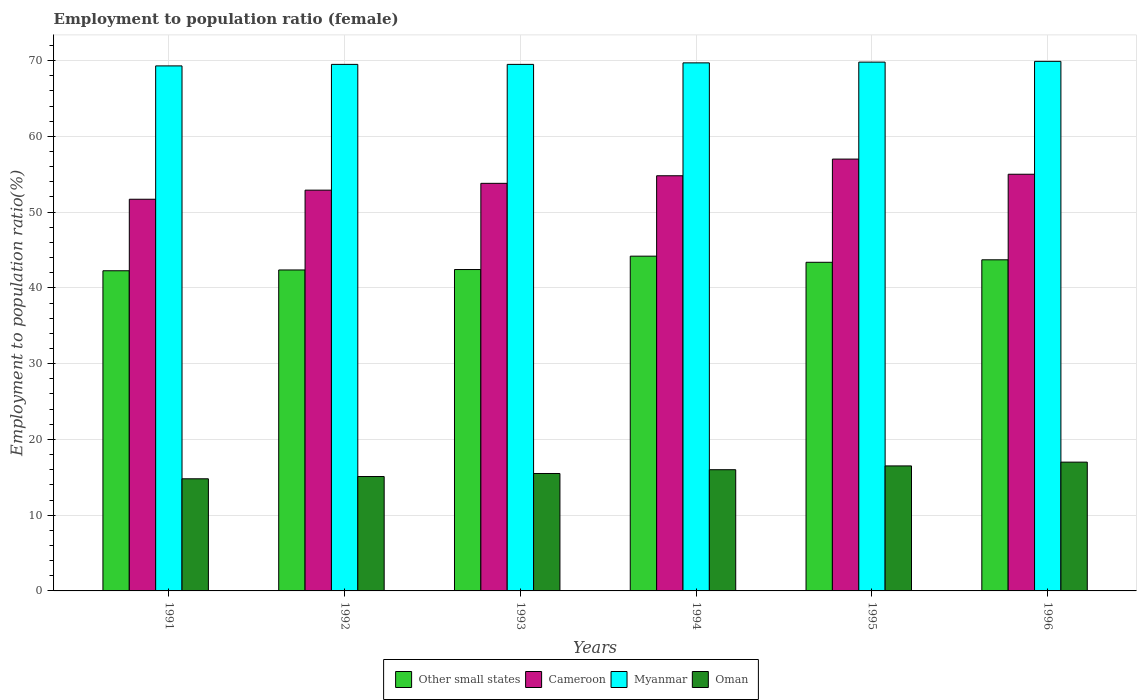How many groups of bars are there?
Offer a terse response. 6. Are the number of bars on each tick of the X-axis equal?
Your response must be concise. Yes. How many bars are there on the 4th tick from the right?
Your response must be concise. 4. What is the label of the 3rd group of bars from the left?
Your answer should be compact. 1993. In how many cases, is the number of bars for a given year not equal to the number of legend labels?
Your answer should be compact. 0. What is the employment to population ratio in Myanmar in 1993?
Your response must be concise. 69.5. Across all years, what is the maximum employment to population ratio in Oman?
Make the answer very short. 17. Across all years, what is the minimum employment to population ratio in Cameroon?
Provide a short and direct response. 51.7. In which year was the employment to population ratio in Cameroon minimum?
Give a very brief answer. 1991. What is the total employment to population ratio in Cameroon in the graph?
Keep it short and to the point. 325.2. What is the difference between the employment to population ratio in Cameroon in 1991 and the employment to population ratio in Oman in 1996?
Offer a terse response. 34.7. What is the average employment to population ratio in Other small states per year?
Ensure brevity in your answer.  43.05. In the year 1995, what is the difference between the employment to population ratio in Cameroon and employment to population ratio in Oman?
Ensure brevity in your answer.  40.5. In how many years, is the employment to population ratio in Oman greater than 60 %?
Ensure brevity in your answer.  0. What is the ratio of the employment to population ratio in Other small states in 1992 to that in 1996?
Offer a terse response. 0.97. What is the difference between the highest and the lowest employment to population ratio in Oman?
Provide a succinct answer. 2.2. In how many years, is the employment to population ratio in Other small states greater than the average employment to population ratio in Other small states taken over all years?
Offer a terse response. 3. What does the 1st bar from the left in 1996 represents?
Keep it short and to the point. Other small states. What does the 4th bar from the right in 1996 represents?
Provide a short and direct response. Other small states. Is it the case that in every year, the sum of the employment to population ratio in Myanmar and employment to population ratio in Cameroon is greater than the employment to population ratio in Oman?
Give a very brief answer. Yes. Are all the bars in the graph horizontal?
Your answer should be very brief. No. How many years are there in the graph?
Offer a very short reply. 6. What is the difference between two consecutive major ticks on the Y-axis?
Your answer should be compact. 10. Are the values on the major ticks of Y-axis written in scientific E-notation?
Your response must be concise. No. Does the graph contain any zero values?
Make the answer very short. No. Does the graph contain grids?
Offer a terse response. Yes. Where does the legend appear in the graph?
Your answer should be compact. Bottom center. How are the legend labels stacked?
Make the answer very short. Horizontal. What is the title of the graph?
Your answer should be compact. Employment to population ratio (female). Does "Tanzania" appear as one of the legend labels in the graph?
Your response must be concise. No. What is the label or title of the X-axis?
Your answer should be very brief. Years. What is the label or title of the Y-axis?
Your answer should be compact. Employment to population ratio(%). What is the Employment to population ratio(%) in Other small states in 1991?
Your answer should be compact. 42.26. What is the Employment to population ratio(%) of Cameroon in 1991?
Your response must be concise. 51.7. What is the Employment to population ratio(%) in Myanmar in 1991?
Your answer should be very brief. 69.3. What is the Employment to population ratio(%) of Oman in 1991?
Your answer should be very brief. 14.8. What is the Employment to population ratio(%) in Other small states in 1992?
Make the answer very short. 42.36. What is the Employment to population ratio(%) of Cameroon in 1992?
Your answer should be compact. 52.9. What is the Employment to population ratio(%) of Myanmar in 1992?
Keep it short and to the point. 69.5. What is the Employment to population ratio(%) in Oman in 1992?
Your answer should be very brief. 15.1. What is the Employment to population ratio(%) in Other small states in 1993?
Give a very brief answer. 42.42. What is the Employment to population ratio(%) in Cameroon in 1993?
Give a very brief answer. 53.8. What is the Employment to population ratio(%) in Myanmar in 1993?
Your response must be concise. 69.5. What is the Employment to population ratio(%) in Other small states in 1994?
Provide a succinct answer. 44.19. What is the Employment to population ratio(%) of Cameroon in 1994?
Your answer should be very brief. 54.8. What is the Employment to population ratio(%) of Myanmar in 1994?
Your answer should be very brief. 69.7. What is the Employment to population ratio(%) in Oman in 1994?
Your answer should be very brief. 16. What is the Employment to population ratio(%) of Other small states in 1995?
Give a very brief answer. 43.38. What is the Employment to population ratio(%) in Cameroon in 1995?
Offer a terse response. 57. What is the Employment to population ratio(%) of Myanmar in 1995?
Ensure brevity in your answer.  69.8. What is the Employment to population ratio(%) of Oman in 1995?
Your answer should be very brief. 16.5. What is the Employment to population ratio(%) in Other small states in 1996?
Your response must be concise. 43.71. What is the Employment to population ratio(%) in Myanmar in 1996?
Ensure brevity in your answer.  69.9. What is the Employment to population ratio(%) of Oman in 1996?
Your answer should be very brief. 17. Across all years, what is the maximum Employment to population ratio(%) in Other small states?
Give a very brief answer. 44.19. Across all years, what is the maximum Employment to population ratio(%) in Myanmar?
Offer a very short reply. 69.9. Across all years, what is the minimum Employment to population ratio(%) of Other small states?
Offer a very short reply. 42.26. Across all years, what is the minimum Employment to population ratio(%) of Cameroon?
Keep it short and to the point. 51.7. Across all years, what is the minimum Employment to population ratio(%) of Myanmar?
Offer a very short reply. 69.3. Across all years, what is the minimum Employment to population ratio(%) of Oman?
Your answer should be compact. 14.8. What is the total Employment to population ratio(%) of Other small states in the graph?
Your answer should be very brief. 258.31. What is the total Employment to population ratio(%) of Cameroon in the graph?
Make the answer very short. 325.2. What is the total Employment to population ratio(%) in Myanmar in the graph?
Offer a very short reply. 417.7. What is the total Employment to population ratio(%) in Oman in the graph?
Your response must be concise. 94.9. What is the difference between the Employment to population ratio(%) in Other small states in 1991 and that in 1992?
Your answer should be compact. -0.1. What is the difference between the Employment to population ratio(%) in Myanmar in 1991 and that in 1992?
Offer a terse response. -0.2. What is the difference between the Employment to population ratio(%) in Other small states in 1991 and that in 1993?
Your answer should be very brief. -0.16. What is the difference between the Employment to population ratio(%) of Cameroon in 1991 and that in 1993?
Your response must be concise. -2.1. What is the difference between the Employment to population ratio(%) in Other small states in 1991 and that in 1994?
Make the answer very short. -1.93. What is the difference between the Employment to population ratio(%) of Myanmar in 1991 and that in 1994?
Provide a succinct answer. -0.4. What is the difference between the Employment to population ratio(%) in Other small states in 1991 and that in 1995?
Provide a succinct answer. -1.12. What is the difference between the Employment to population ratio(%) in Other small states in 1991 and that in 1996?
Keep it short and to the point. -1.45. What is the difference between the Employment to population ratio(%) in Oman in 1991 and that in 1996?
Provide a succinct answer. -2.2. What is the difference between the Employment to population ratio(%) in Other small states in 1992 and that in 1993?
Provide a succinct answer. -0.06. What is the difference between the Employment to population ratio(%) of Myanmar in 1992 and that in 1993?
Provide a short and direct response. 0. What is the difference between the Employment to population ratio(%) of Other small states in 1992 and that in 1994?
Give a very brief answer. -1.82. What is the difference between the Employment to population ratio(%) in Cameroon in 1992 and that in 1994?
Your answer should be very brief. -1.9. What is the difference between the Employment to population ratio(%) in Myanmar in 1992 and that in 1994?
Make the answer very short. -0.2. What is the difference between the Employment to population ratio(%) in Other small states in 1992 and that in 1995?
Make the answer very short. -1.01. What is the difference between the Employment to population ratio(%) in Cameroon in 1992 and that in 1995?
Keep it short and to the point. -4.1. What is the difference between the Employment to population ratio(%) of Oman in 1992 and that in 1995?
Give a very brief answer. -1.4. What is the difference between the Employment to population ratio(%) in Other small states in 1992 and that in 1996?
Provide a short and direct response. -1.34. What is the difference between the Employment to population ratio(%) in Cameroon in 1992 and that in 1996?
Provide a succinct answer. -2.1. What is the difference between the Employment to population ratio(%) of Myanmar in 1992 and that in 1996?
Provide a short and direct response. -0.4. What is the difference between the Employment to population ratio(%) of Other small states in 1993 and that in 1994?
Your answer should be very brief. -1.76. What is the difference between the Employment to population ratio(%) of Cameroon in 1993 and that in 1994?
Provide a succinct answer. -1. What is the difference between the Employment to population ratio(%) in Myanmar in 1993 and that in 1994?
Provide a short and direct response. -0.2. What is the difference between the Employment to population ratio(%) of Oman in 1993 and that in 1994?
Provide a succinct answer. -0.5. What is the difference between the Employment to population ratio(%) of Other small states in 1993 and that in 1995?
Your answer should be very brief. -0.96. What is the difference between the Employment to population ratio(%) of Oman in 1993 and that in 1995?
Your response must be concise. -1. What is the difference between the Employment to population ratio(%) of Other small states in 1993 and that in 1996?
Offer a terse response. -1.29. What is the difference between the Employment to population ratio(%) in Myanmar in 1993 and that in 1996?
Give a very brief answer. -0.4. What is the difference between the Employment to population ratio(%) of Oman in 1993 and that in 1996?
Your response must be concise. -1.5. What is the difference between the Employment to population ratio(%) in Other small states in 1994 and that in 1995?
Your answer should be compact. 0.81. What is the difference between the Employment to population ratio(%) of Myanmar in 1994 and that in 1995?
Provide a succinct answer. -0.1. What is the difference between the Employment to population ratio(%) in Other small states in 1994 and that in 1996?
Your response must be concise. 0.48. What is the difference between the Employment to population ratio(%) of Cameroon in 1994 and that in 1996?
Your answer should be compact. -0.2. What is the difference between the Employment to population ratio(%) in Myanmar in 1994 and that in 1996?
Your response must be concise. -0.2. What is the difference between the Employment to population ratio(%) in Other small states in 1995 and that in 1996?
Provide a succinct answer. -0.33. What is the difference between the Employment to population ratio(%) in Other small states in 1991 and the Employment to population ratio(%) in Cameroon in 1992?
Ensure brevity in your answer.  -10.64. What is the difference between the Employment to population ratio(%) of Other small states in 1991 and the Employment to population ratio(%) of Myanmar in 1992?
Ensure brevity in your answer.  -27.24. What is the difference between the Employment to population ratio(%) in Other small states in 1991 and the Employment to population ratio(%) in Oman in 1992?
Ensure brevity in your answer.  27.16. What is the difference between the Employment to population ratio(%) in Cameroon in 1991 and the Employment to population ratio(%) in Myanmar in 1992?
Your response must be concise. -17.8. What is the difference between the Employment to population ratio(%) in Cameroon in 1991 and the Employment to population ratio(%) in Oman in 1992?
Your answer should be very brief. 36.6. What is the difference between the Employment to population ratio(%) in Myanmar in 1991 and the Employment to population ratio(%) in Oman in 1992?
Provide a succinct answer. 54.2. What is the difference between the Employment to population ratio(%) of Other small states in 1991 and the Employment to population ratio(%) of Cameroon in 1993?
Keep it short and to the point. -11.54. What is the difference between the Employment to population ratio(%) of Other small states in 1991 and the Employment to population ratio(%) of Myanmar in 1993?
Keep it short and to the point. -27.24. What is the difference between the Employment to population ratio(%) in Other small states in 1991 and the Employment to population ratio(%) in Oman in 1993?
Make the answer very short. 26.76. What is the difference between the Employment to population ratio(%) in Cameroon in 1991 and the Employment to population ratio(%) in Myanmar in 1993?
Provide a succinct answer. -17.8. What is the difference between the Employment to population ratio(%) of Cameroon in 1991 and the Employment to population ratio(%) of Oman in 1993?
Make the answer very short. 36.2. What is the difference between the Employment to population ratio(%) of Myanmar in 1991 and the Employment to population ratio(%) of Oman in 1993?
Ensure brevity in your answer.  53.8. What is the difference between the Employment to population ratio(%) of Other small states in 1991 and the Employment to population ratio(%) of Cameroon in 1994?
Ensure brevity in your answer.  -12.54. What is the difference between the Employment to population ratio(%) in Other small states in 1991 and the Employment to population ratio(%) in Myanmar in 1994?
Give a very brief answer. -27.44. What is the difference between the Employment to population ratio(%) of Other small states in 1991 and the Employment to population ratio(%) of Oman in 1994?
Give a very brief answer. 26.26. What is the difference between the Employment to population ratio(%) in Cameroon in 1991 and the Employment to population ratio(%) in Myanmar in 1994?
Ensure brevity in your answer.  -18. What is the difference between the Employment to population ratio(%) of Cameroon in 1991 and the Employment to population ratio(%) of Oman in 1994?
Provide a short and direct response. 35.7. What is the difference between the Employment to population ratio(%) in Myanmar in 1991 and the Employment to population ratio(%) in Oman in 1994?
Ensure brevity in your answer.  53.3. What is the difference between the Employment to population ratio(%) in Other small states in 1991 and the Employment to population ratio(%) in Cameroon in 1995?
Make the answer very short. -14.74. What is the difference between the Employment to population ratio(%) in Other small states in 1991 and the Employment to population ratio(%) in Myanmar in 1995?
Keep it short and to the point. -27.54. What is the difference between the Employment to population ratio(%) of Other small states in 1991 and the Employment to population ratio(%) of Oman in 1995?
Your answer should be compact. 25.76. What is the difference between the Employment to population ratio(%) of Cameroon in 1991 and the Employment to population ratio(%) of Myanmar in 1995?
Offer a very short reply. -18.1. What is the difference between the Employment to population ratio(%) of Cameroon in 1991 and the Employment to population ratio(%) of Oman in 1995?
Provide a short and direct response. 35.2. What is the difference between the Employment to population ratio(%) of Myanmar in 1991 and the Employment to population ratio(%) of Oman in 1995?
Give a very brief answer. 52.8. What is the difference between the Employment to population ratio(%) in Other small states in 1991 and the Employment to population ratio(%) in Cameroon in 1996?
Provide a succinct answer. -12.74. What is the difference between the Employment to population ratio(%) in Other small states in 1991 and the Employment to population ratio(%) in Myanmar in 1996?
Provide a succinct answer. -27.64. What is the difference between the Employment to population ratio(%) in Other small states in 1991 and the Employment to population ratio(%) in Oman in 1996?
Provide a succinct answer. 25.26. What is the difference between the Employment to population ratio(%) of Cameroon in 1991 and the Employment to population ratio(%) of Myanmar in 1996?
Ensure brevity in your answer.  -18.2. What is the difference between the Employment to population ratio(%) of Cameroon in 1991 and the Employment to population ratio(%) of Oman in 1996?
Ensure brevity in your answer.  34.7. What is the difference between the Employment to population ratio(%) of Myanmar in 1991 and the Employment to population ratio(%) of Oman in 1996?
Keep it short and to the point. 52.3. What is the difference between the Employment to population ratio(%) of Other small states in 1992 and the Employment to population ratio(%) of Cameroon in 1993?
Your answer should be very brief. -11.44. What is the difference between the Employment to population ratio(%) of Other small states in 1992 and the Employment to population ratio(%) of Myanmar in 1993?
Provide a succinct answer. -27.14. What is the difference between the Employment to population ratio(%) in Other small states in 1992 and the Employment to population ratio(%) in Oman in 1993?
Give a very brief answer. 26.86. What is the difference between the Employment to population ratio(%) in Cameroon in 1992 and the Employment to population ratio(%) in Myanmar in 1993?
Make the answer very short. -16.6. What is the difference between the Employment to population ratio(%) in Cameroon in 1992 and the Employment to population ratio(%) in Oman in 1993?
Give a very brief answer. 37.4. What is the difference between the Employment to population ratio(%) of Myanmar in 1992 and the Employment to population ratio(%) of Oman in 1993?
Your response must be concise. 54. What is the difference between the Employment to population ratio(%) in Other small states in 1992 and the Employment to population ratio(%) in Cameroon in 1994?
Your response must be concise. -12.44. What is the difference between the Employment to population ratio(%) of Other small states in 1992 and the Employment to population ratio(%) of Myanmar in 1994?
Provide a succinct answer. -27.34. What is the difference between the Employment to population ratio(%) of Other small states in 1992 and the Employment to population ratio(%) of Oman in 1994?
Offer a very short reply. 26.36. What is the difference between the Employment to population ratio(%) of Cameroon in 1992 and the Employment to population ratio(%) of Myanmar in 1994?
Keep it short and to the point. -16.8. What is the difference between the Employment to population ratio(%) of Cameroon in 1992 and the Employment to population ratio(%) of Oman in 1994?
Your response must be concise. 36.9. What is the difference between the Employment to population ratio(%) of Myanmar in 1992 and the Employment to population ratio(%) of Oman in 1994?
Make the answer very short. 53.5. What is the difference between the Employment to population ratio(%) in Other small states in 1992 and the Employment to population ratio(%) in Cameroon in 1995?
Give a very brief answer. -14.64. What is the difference between the Employment to population ratio(%) of Other small states in 1992 and the Employment to population ratio(%) of Myanmar in 1995?
Give a very brief answer. -27.44. What is the difference between the Employment to population ratio(%) of Other small states in 1992 and the Employment to population ratio(%) of Oman in 1995?
Your answer should be very brief. 25.86. What is the difference between the Employment to population ratio(%) in Cameroon in 1992 and the Employment to population ratio(%) in Myanmar in 1995?
Keep it short and to the point. -16.9. What is the difference between the Employment to population ratio(%) of Cameroon in 1992 and the Employment to population ratio(%) of Oman in 1995?
Your answer should be compact. 36.4. What is the difference between the Employment to population ratio(%) in Myanmar in 1992 and the Employment to population ratio(%) in Oman in 1995?
Give a very brief answer. 53. What is the difference between the Employment to population ratio(%) in Other small states in 1992 and the Employment to population ratio(%) in Cameroon in 1996?
Keep it short and to the point. -12.64. What is the difference between the Employment to population ratio(%) in Other small states in 1992 and the Employment to population ratio(%) in Myanmar in 1996?
Your response must be concise. -27.54. What is the difference between the Employment to population ratio(%) of Other small states in 1992 and the Employment to population ratio(%) of Oman in 1996?
Ensure brevity in your answer.  25.36. What is the difference between the Employment to population ratio(%) in Cameroon in 1992 and the Employment to population ratio(%) in Myanmar in 1996?
Make the answer very short. -17. What is the difference between the Employment to population ratio(%) in Cameroon in 1992 and the Employment to population ratio(%) in Oman in 1996?
Provide a short and direct response. 35.9. What is the difference between the Employment to population ratio(%) in Myanmar in 1992 and the Employment to population ratio(%) in Oman in 1996?
Offer a terse response. 52.5. What is the difference between the Employment to population ratio(%) in Other small states in 1993 and the Employment to population ratio(%) in Cameroon in 1994?
Provide a succinct answer. -12.38. What is the difference between the Employment to population ratio(%) of Other small states in 1993 and the Employment to population ratio(%) of Myanmar in 1994?
Offer a very short reply. -27.28. What is the difference between the Employment to population ratio(%) in Other small states in 1993 and the Employment to population ratio(%) in Oman in 1994?
Offer a very short reply. 26.42. What is the difference between the Employment to population ratio(%) of Cameroon in 1993 and the Employment to population ratio(%) of Myanmar in 1994?
Ensure brevity in your answer.  -15.9. What is the difference between the Employment to population ratio(%) in Cameroon in 1993 and the Employment to population ratio(%) in Oman in 1994?
Your answer should be compact. 37.8. What is the difference between the Employment to population ratio(%) of Myanmar in 1993 and the Employment to population ratio(%) of Oman in 1994?
Provide a succinct answer. 53.5. What is the difference between the Employment to population ratio(%) of Other small states in 1993 and the Employment to population ratio(%) of Cameroon in 1995?
Your answer should be compact. -14.58. What is the difference between the Employment to population ratio(%) in Other small states in 1993 and the Employment to population ratio(%) in Myanmar in 1995?
Keep it short and to the point. -27.38. What is the difference between the Employment to population ratio(%) in Other small states in 1993 and the Employment to population ratio(%) in Oman in 1995?
Give a very brief answer. 25.92. What is the difference between the Employment to population ratio(%) in Cameroon in 1993 and the Employment to population ratio(%) in Oman in 1995?
Make the answer very short. 37.3. What is the difference between the Employment to population ratio(%) in Myanmar in 1993 and the Employment to population ratio(%) in Oman in 1995?
Your response must be concise. 53. What is the difference between the Employment to population ratio(%) of Other small states in 1993 and the Employment to population ratio(%) of Cameroon in 1996?
Keep it short and to the point. -12.58. What is the difference between the Employment to population ratio(%) of Other small states in 1993 and the Employment to population ratio(%) of Myanmar in 1996?
Make the answer very short. -27.48. What is the difference between the Employment to population ratio(%) of Other small states in 1993 and the Employment to population ratio(%) of Oman in 1996?
Give a very brief answer. 25.42. What is the difference between the Employment to population ratio(%) of Cameroon in 1993 and the Employment to population ratio(%) of Myanmar in 1996?
Offer a very short reply. -16.1. What is the difference between the Employment to population ratio(%) in Cameroon in 1993 and the Employment to population ratio(%) in Oman in 1996?
Offer a terse response. 36.8. What is the difference between the Employment to population ratio(%) in Myanmar in 1993 and the Employment to population ratio(%) in Oman in 1996?
Provide a short and direct response. 52.5. What is the difference between the Employment to population ratio(%) in Other small states in 1994 and the Employment to population ratio(%) in Cameroon in 1995?
Give a very brief answer. -12.81. What is the difference between the Employment to population ratio(%) in Other small states in 1994 and the Employment to population ratio(%) in Myanmar in 1995?
Give a very brief answer. -25.61. What is the difference between the Employment to population ratio(%) of Other small states in 1994 and the Employment to population ratio(%) of Oman in 1995?
Give a very brief answer. 27.69. What is the difference between the Employment to population ratio(%) in Cameroon in 1994 and the Employment to population ratio(%) in Oman in 1995?
Your answer should be very brief. 38.3. What is the difference between the Employment to population ratio(%) in Myanmar in 1994 and the Employment to population ratio(%) in Oman in 1995?
Provide a short and direct response. 53.2. What is the difference between the Employment to population ratio(%) of Other small states in 1994 and the Employment to population ratio(%) of Cameroon in 1996?
Give a very brief answer. -10.81. What is the difference between the Employment to population ratio(%) in Other small states in 1994 and the Employment to population ratio(%) in Myanmar in 1996?
Your response must be concise. -25.71. What is the difference between the Employment to population ratio(%) in Other small states in 1994 and the Employment to population ratio(%) in Oman in 1996?
Make the answer very short. 27.19. What is the difference between the Employment to population ratio(%) in Cameroon in 1994 and the Employment to population ratio(%) in Myanmar in 1996?
Give a very brief answer. -15.1. What is the difference between the Employment to population ratio(%) of Cameroon in 1994 and the Employment to population ratio(%) of Oman in 1996?
Offer a terse response. 37.8. What is the difference between the Employment to population ratio(%) in Myanmar in 1994 and the Employment to population ratio(%) in Oman in 1996?
Keep it short and to the point. 52.7. What is the difference between the Employment to population ratio(%) in Other small states in 1995 and the Employment to population ratio(%) in Cameroon in 1996?
Keep it short and to the point. -11.62. What is the difference between the Employment to population ratio(%) in Other small states in 1995 and the Employment to population ratio(%) in Myanmar in 1996?
Your answer should be very brief. -26.52. What is the difference between the Employment to population ratio(%) of Other small states in 1995 and the Employment to population ratio(%) of Oman in 1996?
Make the answer very short. 26.38. What is the difference between the Employment to population ratio(%) in Cameroon in 1995 and the Employment to population ratio(%) in Myanmar in 1996?
Ensure brevity in your answer.  -12.9. What is the difference between the Employment to population ratio(%) of Myanmar in 1995 and the Employment to population ratio(%) of Oman in 1996?
Your response must be concise. 52.8. What is the average Employment to population ratio(%) of Other small states per year?
Keep it short and to the point. 43.05. What is the average Employment to population ratio(%) of Cameroon per year?
Keep it short and to the point. 54.2. What is the average Employment to population ratio(%) of Myanmar per year?
Ensure brevity in your answer.  69.62. What is the average Employment to population ratio(%) of Oman per year?
Ensure brevity in your answer.  15.82. In the year 1991, what is the difference between the Employment to population ratio(%) of Other small states and Employment to population ratio(%) of Cameroon?
Make the answer very short. -9.44. In the year 1991, what is the difference between the Employment to population ratio(%) in Other small states and Employment to population ratio(%) in Myanmar?
Offer a terse response. -27.04. In the year 1991, what is the difference between the Employment to population ratio(%) in Other small states and Employment to population ratio(%) in Oman?
Your answer should be compact. 27.46. In the year 1991, what is the difference between the Employment to population ratio(%) of Cameroon and Employment to population ratio(%) of Myanmar?
Your response must be concise. -17.6. In the year 1991, what is the difference between the Employment to population ratio(%) in Cameroon and Employment to population ratio(%) in Oman?
Your answer should be compact. 36.9. In the year 1991, what is the difference between the Employment to population ratio(%) in Myanmar and Employment to population ratio(%) in Oman?
Make the answer very short. 54.5. In the year 1992, what is the difference between the Employment to population ratio(%) in Other small states and Employment to population ratio(%) in Cameroon?
Your answer should be compact. -10.54. In the year 1992, what is the difference between the Employment to population ratio(%) of Other small states and Employment to population ratio(%) of Myanmar?
Ensure brevity in your answer.  -27.14. In the year 1992, what is the difference between the Employment to population ratio(%) in Other small states and Employment to population ratio(%) in Oman?
Keep it short and to the point. 27.26. In the year 1992, what is the difference between the Employment to population ratio(%) of Cameroon and Employment to population ratio(%) of Myanmar?
Ensure brevity in your answer.  -16.6. In the year 1992, what is the difference between the Employment to population ratio(%) of Cameroon and Employment to population ratio(%) of Oman?
Give a very brief answer. 37.8. In the year 1992, what is the difference between the Employment to population ratio(%) of Myanmar and Employment to population ratio(%) of Oman?
Your answer should be very brief. 54.4. In the year 1993, what is the difference between the Employment to population ratio(%) of Other small states and Employment to population ratio(%) of Cameroon?
Your response must be concise. -11.38. In the year 1993, what is the difference between the Employment to population ratio(%) in Other small states and Employment to population ratio(%) in Myanmar?
Provide a succinct answer. -27.08. In the year 1993, what is the difference between the Employment to population ratio(%) in Other small states and Employment to population ratio(%) in Oman?
Your answer should be very brief. 26.92. In the year 1993, what is the difference between the Employment to population ratio(%) of Cameroon and Employment to population ratio(%) of Myanmar?
Your response must be concise. -15.7. In the year 1993, what is the difference between the Employment to population ratio(%) in Cameroon and Employment to population ratio(%) in Oman?
Give a very brief answer. 38.3. In the year 1993, what is the difference between the Employment to population ratio(%) in Myanmar and Employment to population ratio(%) in Oman?
Keep it short and to the point. 54. In the year 1994, what is the difference between the Employment to population ratio(%) in Other small states and Employment to population ratio(%) in Cameroon?
Your response must be concise. -10.61. In the year 1994, what is the difference between the Employment to population ratio(%) in Other small states and Employment to population ratio(%) in Myanmar?
Make the answer very short. -25.51. In the year 1994, what is the difference between the Employment to population ratio(%) of Other small states and Employment to population ratio(%) of Oman?
Your response must be concise. 28.19. In the year 1994, what is the difference between the Employment to population ratio(%) in Cameroon and Employment to population ratio(%) in Myanmar?
Make the answer very short. -14.9. In the year 1994, what is the difference between the Employment to population ratio(%) in Cameroon and Employment to population ratio(%) in Oman?
Offer a very short reply. 38.8. In the year 1994, what is the difference between the Employment to population ratio(%) of Myanmar and Employment to population ratio(%) of Oman?
Provide a succinct answer. 53.7. In the year 1995, what is the difference between the Employment to population ratio(%) in Other small states and Employment to population ratio(%) in Cameroon?
Your answer should be very brief. -13.62. In the year 1995, what is the difference between the Employment to population ratio(%) of Other small states and Employment to population ratio(%) of Myanmar?
Your response must be concise. -26.42. In the year 1995, what is the difference between the Employment to population ratio(%) of Other small states and Employment to population ratio(%) of Oman?
Your response must be concise. 26.88. In the year 1995, what is the difference between the Employment to population ratio(%) of Cameroon and Employment to population ratio(%) of Myanmar?
Ensure brevity in your answer.  -12.8. In the year 1995, what is the difference between the Employment to population ratio(%) in Cameroon and Employment to population ratio(%) in Oman?
Offer a very short reply. 40.5. In the year 1995, what is the difference between the Employment to population ratio(%) in Myanmar and Employment to population ratio(%) in Oman?
Your answer should be compact. 53.3. In the year 1996, what is the difference between the Employment to population ratio(%) of Other small states and Employment to population ratio(%) of Cameroon?
Ensure brevity in your answer.  -11.29. In the year 1996, what is the difference between the Employment to population ratio(%) in Other small states and Employment to population ratio(%) in Myanmar?
Your answer should be very brief. -26.19. In the year 1996, what is the difference between the Employment to population ratio(%) in Other small states and Employment to population ratio(%) in Oman?
Offer a terse response. 26.71. In the year 1996, what is the difference between the Employment to population ratio(%) in Cameroon and Employment to population ratio(%) in Myanmar?
Ensure brevity in your answer.  -14.9. In the year 1996, what is the difference between the Employment to population ratio(%) in Myanmar and Employment to population ratio(%) in Oman?
Offer a terse response. 52.9. What is the ratio of the Employment to population ratio(%) in Other small states in 1991 to that in 1992?
Your answer should be compact. 1. What is the ratio of the Employment to population ratio(%) in Cameroon in 1991 to that in 1992?
Keep it short and to the point. 0.98. What is the ratio of the Employment to population ratio(%) of Oman in 1991 to that in 1992?
Keep it short and to the point. 0.98. What is the ratio of the Employment to population ratio(%) of Other small states in 1991 to that in 1993?
Make the answer very short. 1. What is the ratio of the Employment to population ratio(%) of Cameroon in 1991 to that in 1993?
Give a very brief answer. 0.96. What is the ratio of the Employment to population ratio(%) of Myanmar in 1991 to that in 1993?
Keep it short and to the point. 1. What is the ratio of the Employment to population ratio(%) of Oman in 1991 to that in 1993?
Make the answer very short. 0.95. What is the ratio of the Employment to population ratio(%) of Other small states in 1991 to that in 1994?
Ensure brevity in your answer.  0.96. What is the ratio of the Employment to population ratio(%) of Cameroon in 1991 to that in 1994?
Make the answer very short. 0.94. What is the ratio of the Employment to population ratio(%) of Myanmar in 1991 to that in 1994?
Give a very brief answer. 0.99. What is the ratio of the Employment to population ratio(%) in Oman in 1991 to that in 1994?
Provide a short and direct response. 0.93. What is the ratio of the Employment to population ratio(%) of Other small states in 1991 to that in 1995?
Your response must be concise. 0.97. What is the ratio of the Employment to population ratio(%) of Cameroon in 1991 to that in 1995?
Ensure brevity in your answer.  0.91. What is the ratio of the Employment to population ratio(%) in Myanmar in 1991 to that in 1995?
Offer a very short reply. 0.99. What is the ratio of the Employment to population ratio(%) in Oman in 1991 to that in 1995?
Offer a very short reply. 0.9. What is the ratio of the Employment to population ratio(%) of Other small states in 1991 to that in 1996?
Offer a terse response. 0.97. What is the ratio of the Employment to population ratio(%) of Myanmar in 1991 to that in 1996?
Your response must be concise. 0.99. What is the ratio of the Employment to population ratio(%) in Oman in 1991 to that in 1996?
Your answer should be compact. 0.87. What is the ratio of the Employment to population ratio(%) of Other small states in 1992 to that in 1993?
Provide a succinct answer. 1. What is the ratio of the Employment to population ratio(%) of Cameroon in 1992 to that in 1993?
Ensure brevity in your answer.  0.98. What is the ratio of the Employment to population ratio(%) in Myanmar in 1992 to that in 1993?
Keep it short and to the point. 1. What is the ratio of the Employment to population ratio(%) of Oman in 1992 to that in 1993?
Offer a terse response. 0.97. What is the ratio of the Employment to population ratio(%) of Other small states in 1992 to that in 1994?
Ensure brevity in your answer.  0.96. What is the ratio of the Employment to population ratio(%) in Cameroon in 1992 to that in 1994?
Your response must be concise. 0.97. What is the ratio of the Employment to population ratio(%) in Oman in 1992 to that in 1994?
Keep it short and to the point. 0.94. What is the ratio of the Employment to population ratio(%) of Other small states in 1992 to that in 1995?
Your answer should be compact. 0.98. What is the ratio of the Employment to population ratio(%) in Cameroon in 1992 to that in 1995?
Make the answer very short. 0.93. What is the ratio of the Employment to population ratio(%) in Oman in 1992 to that in 1995?
Keep it short and to the point. 0.92. What is the ratio of the Employment to population ratio(%) of Other small states in 1992 to that in 1996?
Your response must be concise. 0.97. What is the ratio of the Employment to population ratio(%) in Cameroon in 1992 to that in 1996?
Your answer should be very brief. 0.96. What is the ratio of the Employment to population ratio(%) of Myanmar in 1992 to that in 1996?
Ensure brevity in your answer.  0.99. What is the ratio of the Employment to population ratio(%) of Oman in 1992 to that in 1996?
Keep it short and to the point. 0.89. What is the ratio of the Employment to population ratio(%) of Other small states in 1993 to that in 1994?
Offer a terse response. 0.96. What is the ratio of the Employment to population ratio(%) of Cameroon in 1993 to that in 1994?
Your answer should be compact. 0.98. What is the ratio of the Employment to population ratio(%) of Oman in 1993 to that in 1994?
Keep it short and to the point. 0.97. What is the ratio of the Employment to population ratio(%) in Other small states in 1993 to that in 1995?
Give a very brief answer. 0.98. What is the ratio of the Employment to population ratio(%) in Cameroon in 1993 to that in 1995?
Keep it short and to the point. 0.94. What is the ratio of the Employment to population ratio(%) in Myanmar in 1993 to that in 1995?
Keep it short and to the point. 1. What is the ratio of the Employment to population ratio(%) of Oman in 1993 to that in 1995?
Provide a succinct answer. 0.94. What is the ratio of the Employment to population ratio(%) in Other small states in 1993 to that in 1996?
Keep it short and to the point. 0.97. What is the ratio of the Employment to population ratio(%) in Cameroon in 1993 to that in 1996?
Provide a short and direct response. 0.98. What is the ratio of the Employment to population ratio(%) in Oman in 1993 to that in 1996?
Provide a succinct answer. 0.91. What is the ratio of the Employment to population ratio(%) of Other small states in 1994 to that in 1995?
Your answer should be very brief. 1.02. What is the ratio of the Employment to population ratio(%) of Cameroon in 1994 to that in 1995?
Provide a succinct answer. 0.96. What is the ratio of the Employment to population ratio(%) in Oman in 1994 to that in 1995?
Offer a very short reply. 0.97. What is the ratio of the Employment to population ratio(%) in Myanmar in 1994 to that in 1996?
Give a very brief answer. 1. What is the ratio of the Employment to population ratio(%) of Cameroon in 1995 to that in 1996?
Keep it short and to the point. 1.04. What is the ratio of the Employment to population ratio(%) of Myanmar in 1995 to that in 1996?
Your answer should be very brief. 1. What is the ratio of the Employment to population ratio(%) in Oman in 1995 to that in 1996?
Provide a succinct answer. 0.97. What is the difference between the highest and the second highest Employment to population ratio(%) in Other small states?
Your response must be concise. 0.48. What is the difference between the highest and the second highest Employment to population ratio(%) in Myanmar?
Offer a terse response. 0.1. What is the difference between the highest and the lowest Employment to population ratio(%) of Other small states?
Provide a succinct answer. 1.93. What is the difference between the highest and the lowest Employment to population ratio(%) in Cameroon?
Offer a terse response. 5.3. 